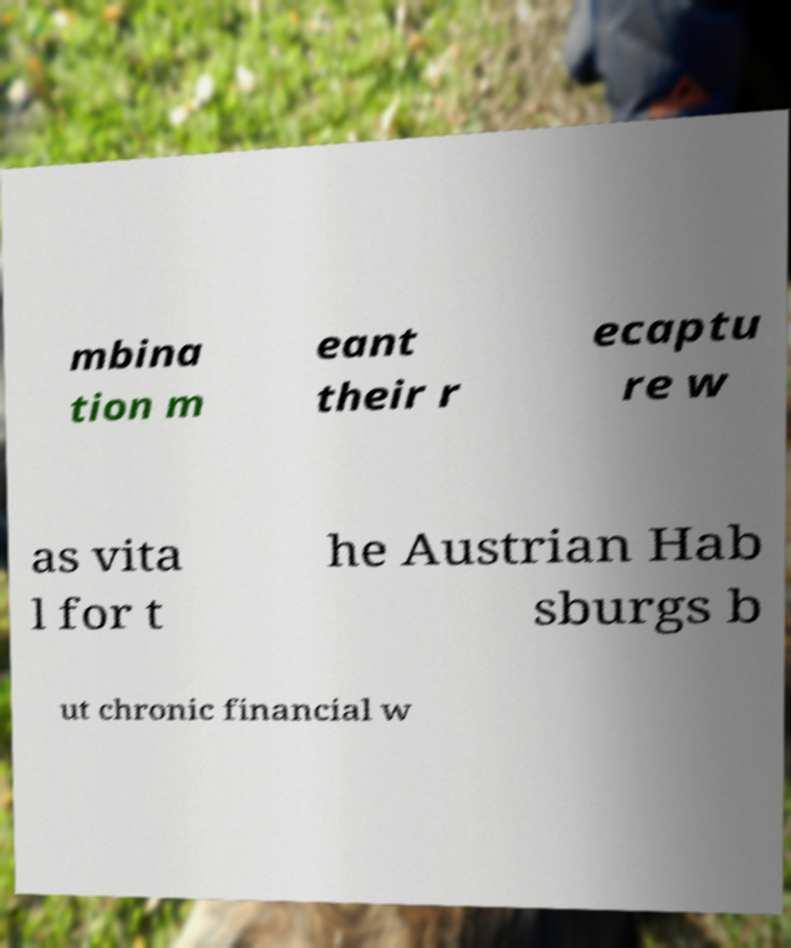What messages or text are displayed in this image? I need them in a readable, typed format. mbina tion m eant their r ecaptu re w as vita l for t he Austrian Hab sburgs b ut chronic financial w 